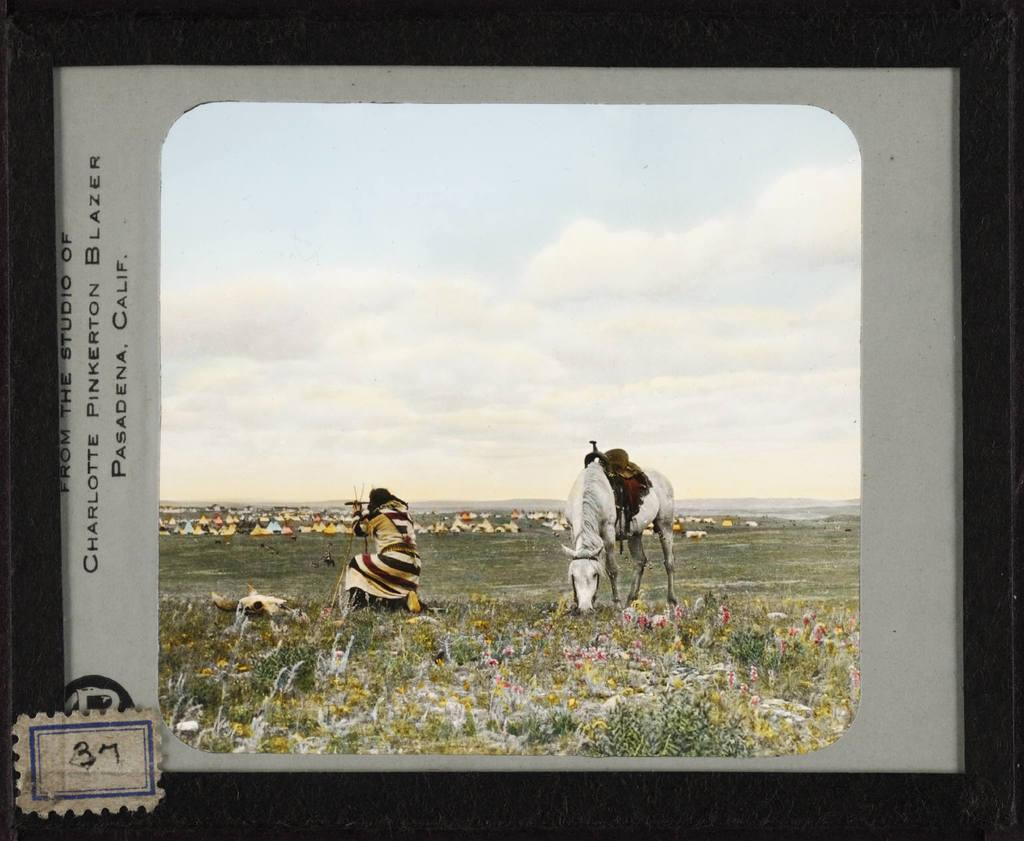<image>
Offer a succinct explanation of the picture presented. A painting of a native american man next to a horse that is labeled Pasadena Calif. 